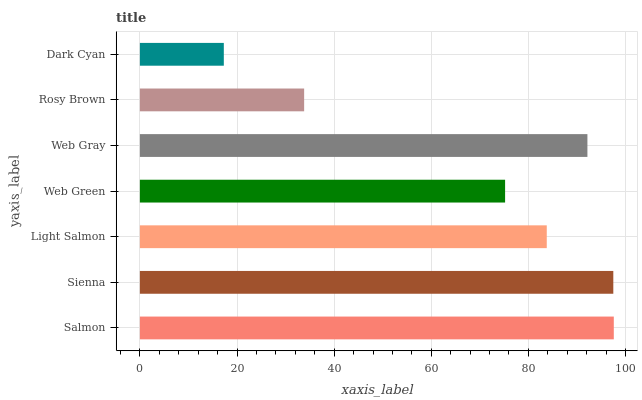Is Dark Cyan the minimum?
Answer yes or no. Yes. Is Salmon the maximum?
Answer yes or no. Yes. Is Sienna the minimum?
Answer yes or no. No. Is Sienna the maximum?
Answer yes or no. No. Is Salmon greater than Sienna?
Answer yes or no. Yes. Is Sienna less than Salmon?
Answer yes or no. Yes. Is Sienna greater than Salmon?
Answer yes or no. No. Is Salmon less than Sienna?
Answer yes or no. No. Is Light Salmon the high median?
Answer yes or no. Yes. Is Light Salmon the low median?
Answer yes or no. Yes. Is Web Green the high median?
Answer yes or no. No. Is Salmon the low median?
Answer yes or no. No. 